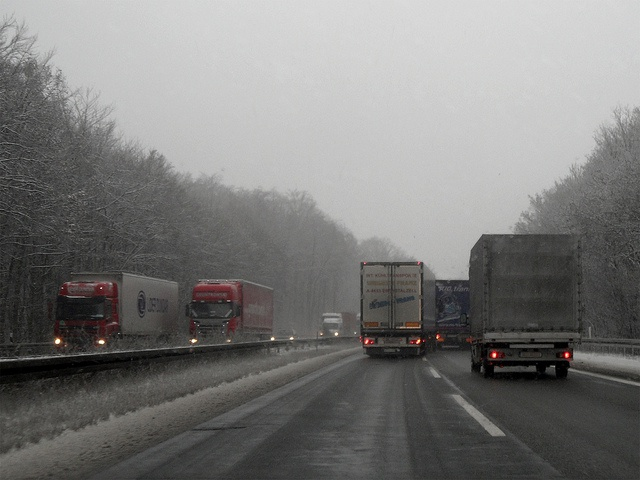Describe the objects in this image and their specific colors. I can see truck in lightgray, black, gray, and maroon tones, truck in lightgray, black, gray, and maroon tones, truck in lightgray, gray, black, and maroon tones, truck in lightgray, gray, black, and maroon tones, and truck in lightgray, black, gray, and maroon tones in this image. 